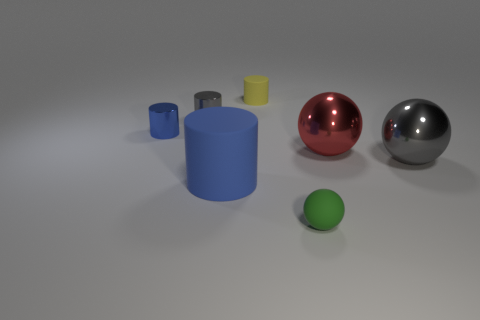There is a small matte object to the left of the small matte object in front of the tiny yellow rubber cylinder; what color is it? The small matte object to the left of the one in front of the tiny yellow rubber cylinder is blue. 